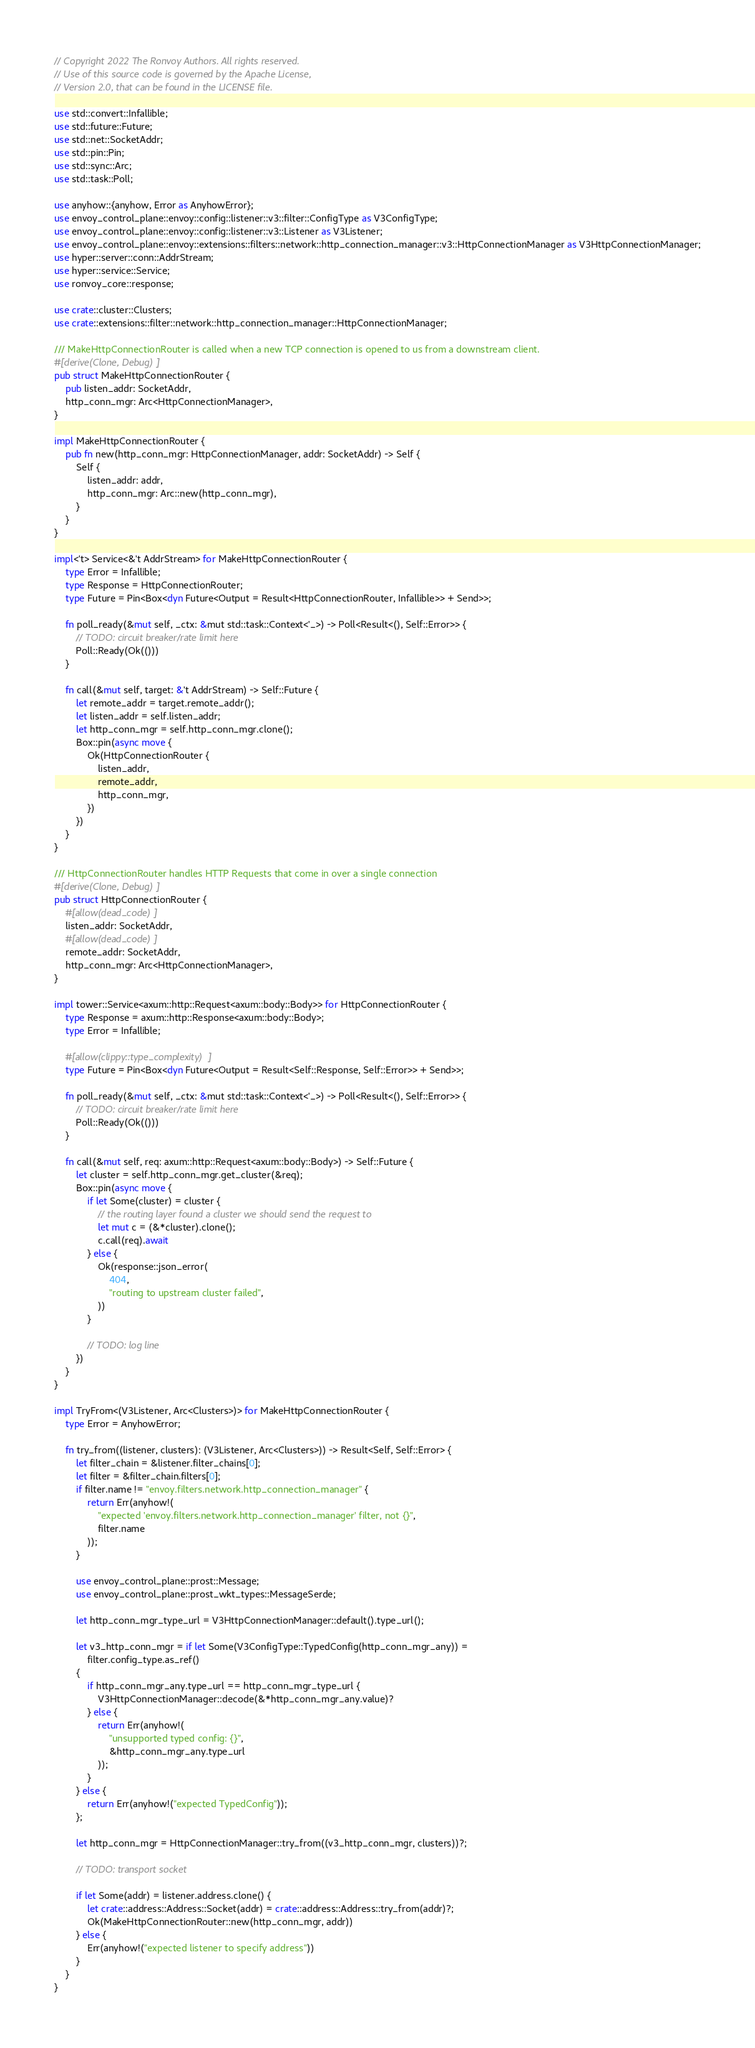<code> <loc_0><loc_0><loc_500><loc_500><_Rust_>// Copyright 2022 The Ronvoy Authors. All rights reserved.
// Use of this source code is governed by the Apache License,
// Version 2.0, that can be found in the LICENSE file.

use std::convert::Infallible;
use std::future::Future;
use std::net::SocketAddr;
use std::pin::Pin;
use std::sync::Arc;
use std::task::Poll;

use anyhow::{anyhow, Error as AnyhowError};
use envoy_control_plane::envoy::config::listener::v3::filter::ConfigType as V3ConfigType;
use envoy_control_plane::envoy::config::listener::v3::Listener as V3Listener;
use envoy_control_plane::envoy::extensions::filters::network::http_connection_manager::v3::HttpConnectionManager as V3HttpConnectionManager;
use hyper::server::conn::AddrStream;
use hyper::service::Service;
use ronvoy_core::response;

use crate::cluster::Clusters;
use crate::extensions::filter::network::http_connection_manager::HttpConnectionManager;

/// MakeHttpConnectionRouter is called when a new TCP connection is opened to us from a downstream client.
#[derive(Clone, Debug)]
pub struct MakeHttpConnectionRouter {
    pub listen_addr: SocketAddr,
    http_conn_mgr: Arc<HttpConnectionManager>,
}

impl MakeHttpConnectionRouter {
    pub fn new(http_conn_mgr: HttpConnectionManager, addr: SocketAddr) -> Self {
        Self {
            listen_addr: addr,
            http_conn_mgr: Arc::new(http_conn_mgr),
        }
    }
}

impl<'t> Service<&'t AddrStream> for MakeHttpConnectionRouter {
    type Error = Infallible;
    type Response = HttpConnectionRouter;
    type Future = Pin<Box<dyn Future<Output = Result<HttpConnectionRouter, Infallible>> + Send>>;

    fn poll_ready(&mut self, _ctx: &mut std::task::Context<'_>) -> Poll<Result<(), Self::Error>> {
        // TODO: circuit breaker/rate limit here
        Poll::Ready(Ok(()))
    }

    fn call(&mut self, target: &'t AddrStream) -> Self::Future {
        let remote_addr = target.remote_addr();
        let listen_addr = self.listen_addr;
        let http_conn_mgr = self.http_conn_mgr.clone();
        Box::pin(async move {
            Ok(HttpConnectionRouter {
                listen_addr,
                remote_addr,
                http_conn_mgr,
            })
        })
    }
}

/// HttpConnectionRouter handles HTTP Requests that come in over a single connection
#[derive(Clone, Debug)]
pub struct HttpConnectionRouter {
    #[allow(dead_code)]
    listen_addr: SocketAddr,
    #[allow(dead_code)]
    remote_addr: SocketAddr,
    http_conn_mgr: Arc<HttpConnectionManager>,
}

impl tower::Service<axum::http::Request<axum::body::Body>> for HttpConnectionRouter {
    type Response = axum::http::Response<axum::body::Body>;
    type Error = Infallible;

    #[allow(clippy::type_complexity)]
    type Future = Pin<Box<dyn Future<Output = Result<Self::Response, Self::Error>> + Send>>;

    fn poll_ready(&mut self, _ctx: &mut std::task::Context<'_>) -> Poll<Result<(), Self::Error>> {
        // TODO: circuit breaker/rate limit here
        Poll::Ready(Ok(()))
    }

    fn call(&mut self, req: axum::http::Request<axum::body::Body>) -> Self::Future {
        let cluster = self.http_conn_mgr.get_cluster(&req);
        Box::pin(async move {
            if let Some(cluster) = cluster {
                // the routing layer found a cluster we should send the request to
                let mut c = (&*cluster).clone();
                c.call(req).await
            } else {
                Ok(response::json_error(
                    404,
                    "routing to upstream cluster failed",
                ))
            }

            // TODO: log line
        })
    }
}

impl TryFrom<(V3Listener, Arc<Clusters>)> for MakeHttpConnectionRouter {
    type Error = AnyhowError;

    fn try_from((listener, clusters): (V3Listener, Arc<Clusters>)) -> Result<Self, Self::Error> {
        let filter_chain = &listener.filter_chains[0];
        let filter = &filter_chain.filters[0];
        if filter.name != "envoy.filters.network.http_connection_manager" {
            return Err(anyhow!(
                "expected 'envoy.filters.network.http_connection_manager' filter, not {}",
                filter.name
            ));
        }

        use envoy_control_plane::prost::Message;
        use envoy_control_plane::prost_wkt_types::MessageSerde;

        let http_conn_mgr_type_url = V3HttpConnectionManager::default().type_url();

        let v3_http_conn_mgr = if let Some(V3ConfigType::TypedConfig(http_conn_mgr_any)) =
            filter.config_type.as_ref()
        {
            if http_conn_mgr_any.type_url == http_conn_mgr_type_url {
                V3HttpConnectionManager::decode(&*http_conn_mgr_any.value)?
            } else {
                return Err(anyhow!(
                    "unsupported typed config: {}",
                    &http_conn_mgr_any.type_url
                ));
            }
        } else {
            return Err(anyhow!("expected TypedConfig"));
        };

        let http_conn_mgr = HttpConnectionManager::try_from((v3_http_conn_mgr, clusters))?;

        // TODO: transport socket

        if let Some(addr) = listener.address.clone() {
            let crate::address::Address::Socket(addr) = crate::address::Address::try_from(addr)?;
            Ok(MakeHttpConnectionRouter::new(http_conn_mgr, addr))
        } else {
            Err(anyhow!("expected listener to specify address"))
        }
    }
}
</code> 